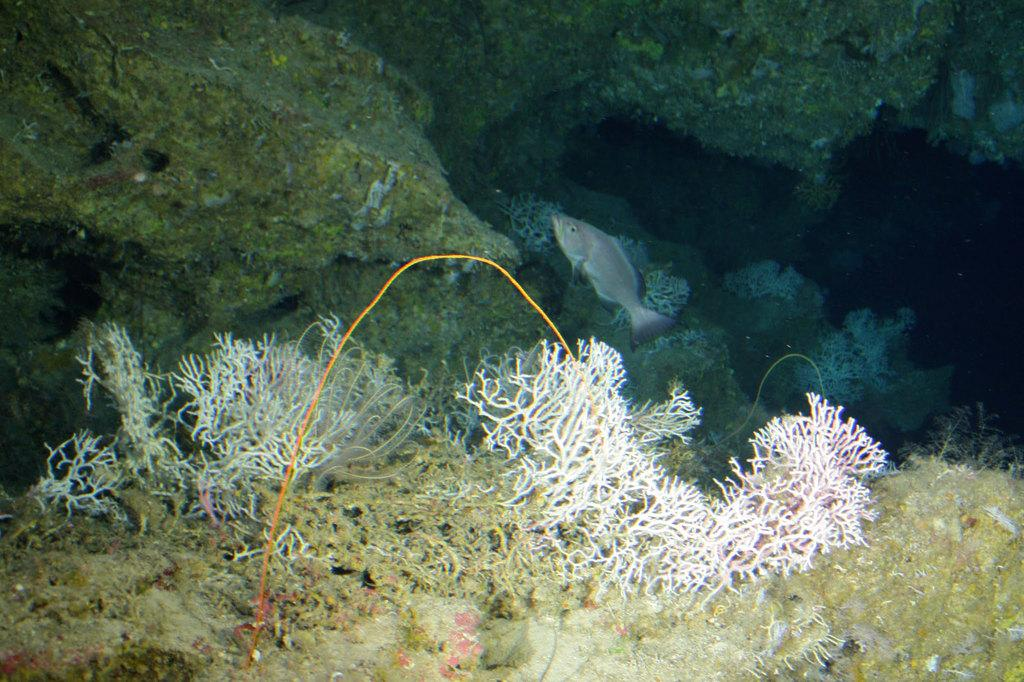What type of animal is in the image? There is a fish in the image. What else can be seen in the water with the fish? There are rocks and corals in the image. What is the environment in which the fish, rocks, and corals are located? The fish, rocks, and corals are in water. Who is the owner of the fish in the image? There is no indication of an owner in the image, as it is a natural underwater scene. 